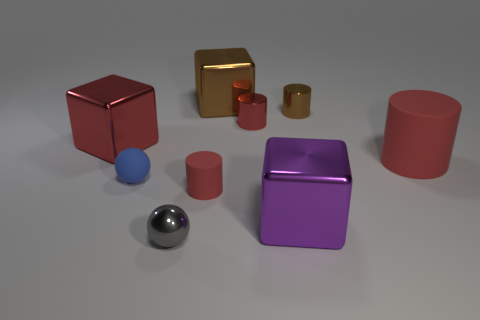Subtract all red spheres. How many red cylinders are left? 3 Add 1 tiny metal balls. How many objects exist? 10 Subtract all cubes. How many objects are left? 6 Subtract 0 blue cylinders. How many objects are left? 9 Subtract all cyan matte things. Subtract all blue matte objects. How many objects are left? 8 Add 2 purple blocks. How many purple blocks are left? 3 Add 1 blue rubber things. How many blue rubber things exist? 2 